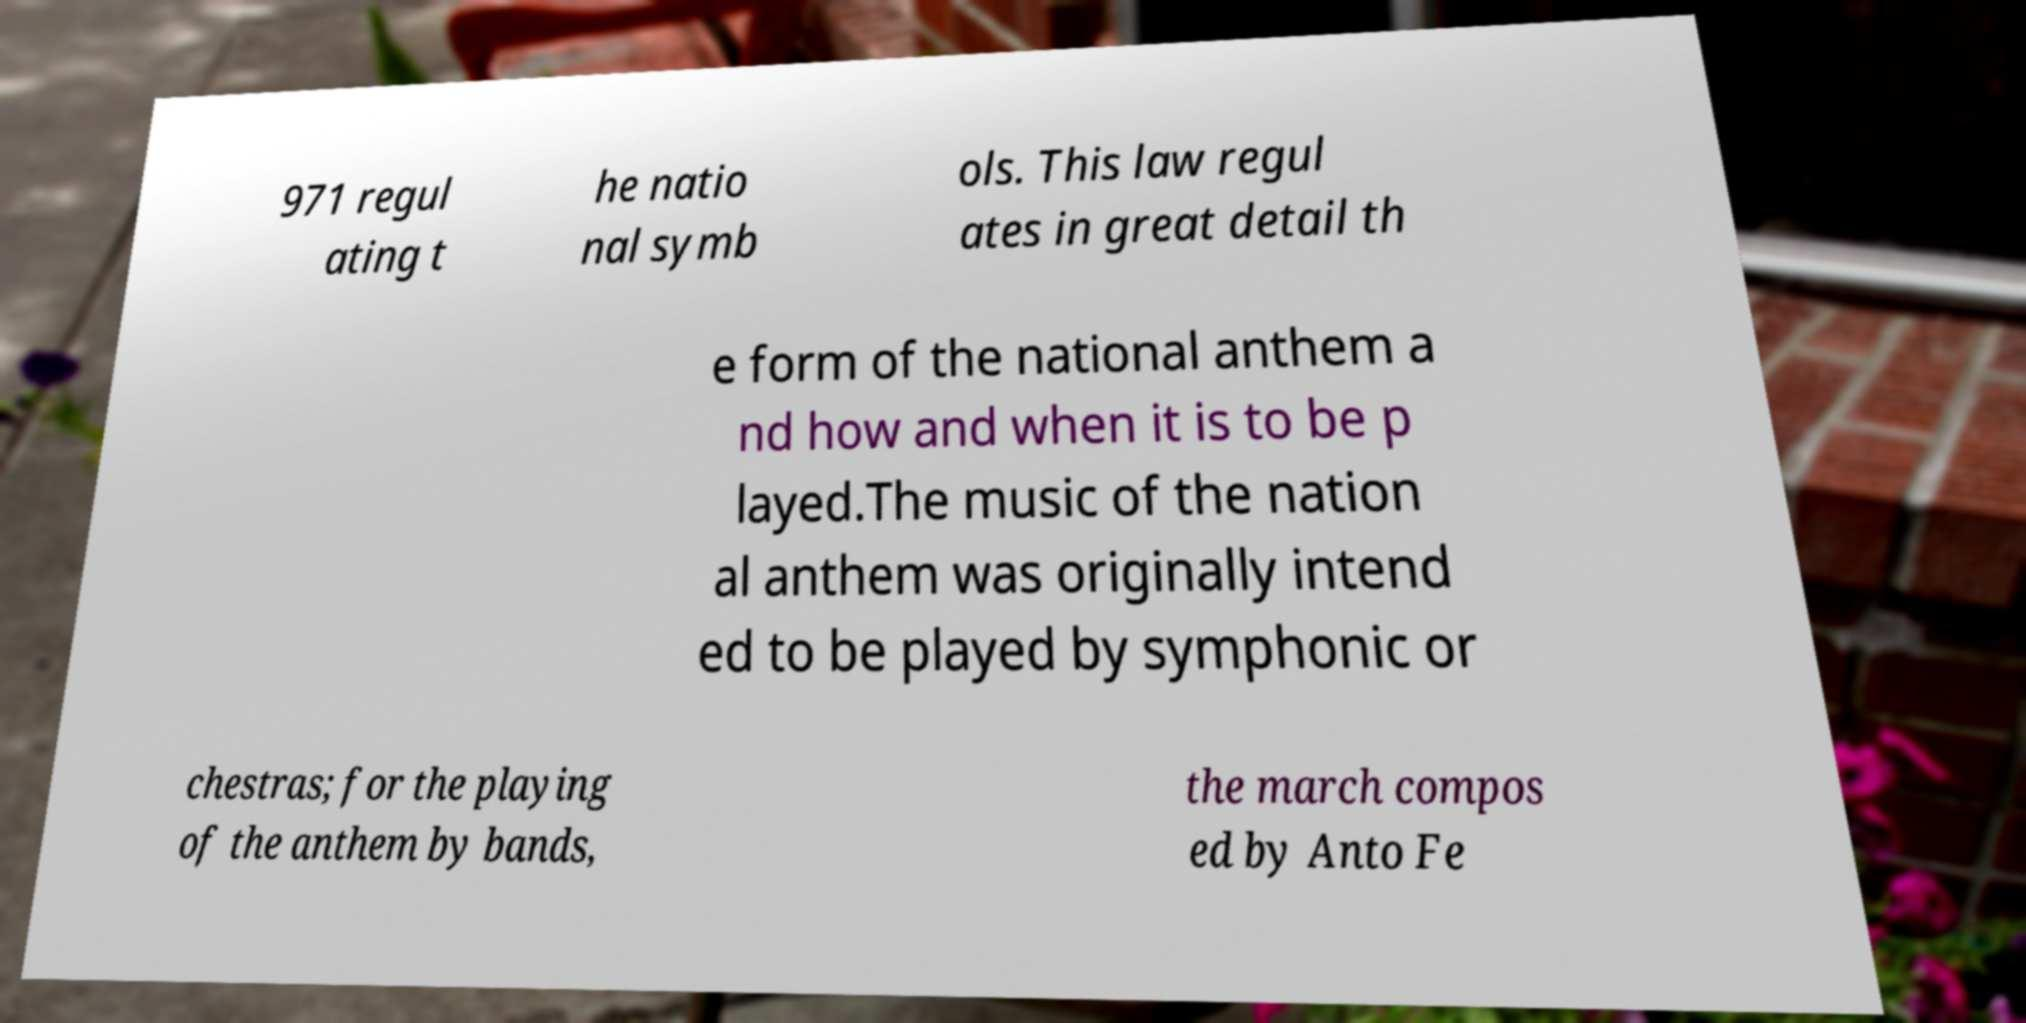Can you read and provide the text displayed in the image?This photo seems to have some interesting text. Can you extract and type it out for me? 971 regul ating t he natio nal symb ols. This law regul ates in great detail th e form of the national anthem a nd how and when it is to be p layed.The music of the nation al anthem was originally intend ed to be played by symphonic or chestras; for the playing of the anthem by bands, the march compos ed by Anto Fe 